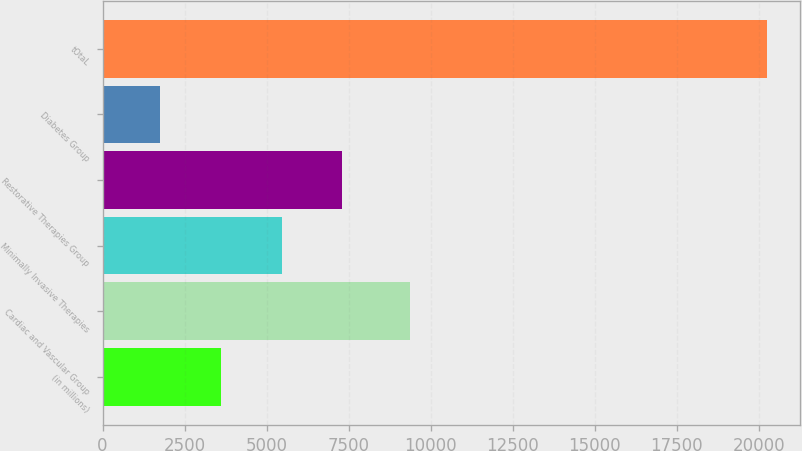<chart> <loc_0><loc_0><loc_500><loc_500><bar_chart><fcel>(in millions)<fcel>Cardiac and Vascular Group<fcel>Minimally Invasive Therapies<fcel>Restorative Therapies Group<fcel>Diabetes Group<fcel>tOtaL<nl><fcel>3611.9<fcel>9361<fcel>5461.8<fcel>7311.7<fcel>1762<fcel>20261<nl></chart> 